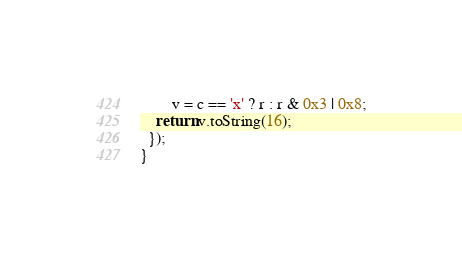<code> <loc_0><loc_0><loc_500><loc_500><_JavaScript_>        v = c == 'x' ? r : r & 0x3 | 0x8;
    return v.toString(16);
  });
}</code> 